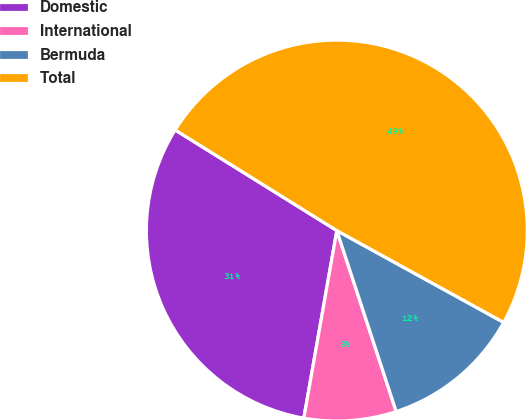Convert chart. <chart><loc_0><loc_0><loc_500><loc_500><pie_chart><fcel>Domestic<fcel>International<fcel>Bermuda<fcel>Total<nl><fcel>31.09%<fcel>7.82%<fcel>11.95%<fcel>49.15%<nl></chart> 